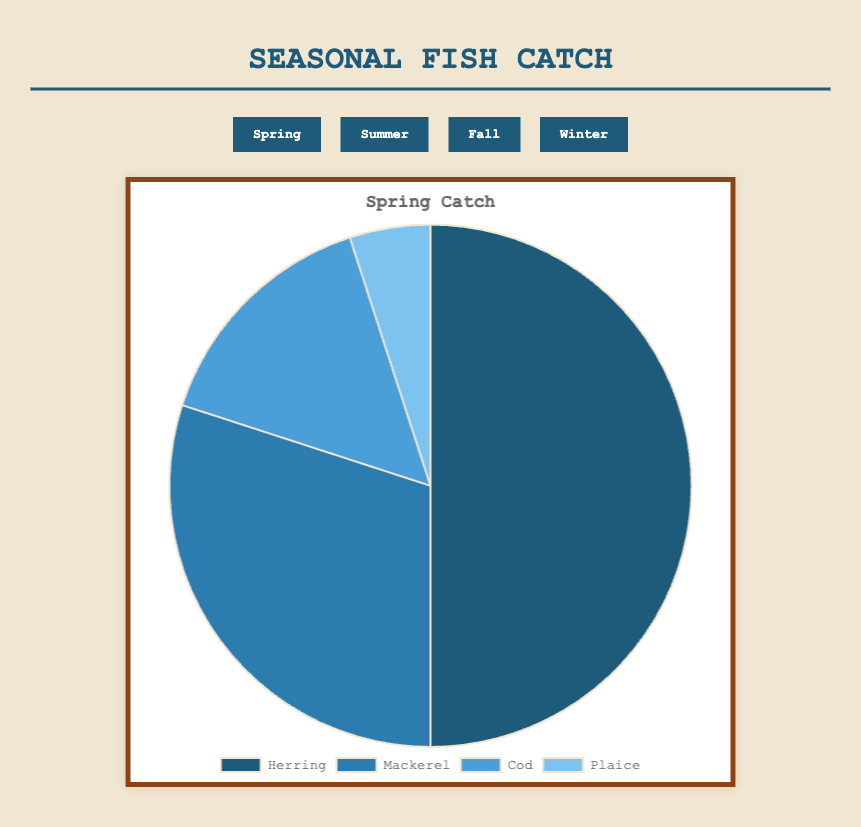Which season has the highest total catch of fish? To determine the highest total catch, we need to sum the quantities of all types of fish for each season. Spring: 1000 (500+300+150+50), Summer: 1570 (700+500+200+100+70), Fall: 1150 (400+300+200+100+150), Winter: 1310 (600+400+250+60). Summer has the highest total catch.
Answer: Summer In which season is the Herring catch the highest? We compare the Herring catch across all seasons: Spring: 500, Summer: 700, Fall: 400, Winter: 600. Herring catch is highest in Summer.
Answer: Summer What’s the combined catch of Mackerel and Cod in Winter? In Winter, Mackerel catch is 400 and Cod catch is 250. Adding these values gives us 400 + 250 = 650.
Answer: 650 Which season has the least Plaice catch? Comparing the Plaice catch for each season: Spring: 50, Summer: 70, Fall: 100, Winter: 60. The least Plaice catch is in Spring.
Answer: Spring How does the Tuna catch in Summer compare to the total catch of Plaice in all seasons? First, note that Tuna is only caught in Summer (200). The total Plaice catch in all seasons is: Spring: 50, Summer: 70, Fall: 100, Winter: 60. Summing these gives 50 + 70 + 100 + 60 = 280. Tuna catch in Summer (200) is less than total Plaice catch (280).
Answer: Less than What’s the percentage of Cod in Fall relative to the total catch in Fall? The total catch in Fall is 1150. Cod catch in Fall is 200. To calculate the percentage: (200 / 1150) * 100 ≈ 17.39%.
Answer: 17.39% Comparing Spring and Winter, which season has a higher Mackerel catch? In Spring, Mackerel catch is 300. In Winter, it is 400. Winter has a higher Mackerel catch.
Answer: Winter Which fish type sees an introduction that is only available in a single season? Tuna appears only in Summer.
Answer: Tuna 